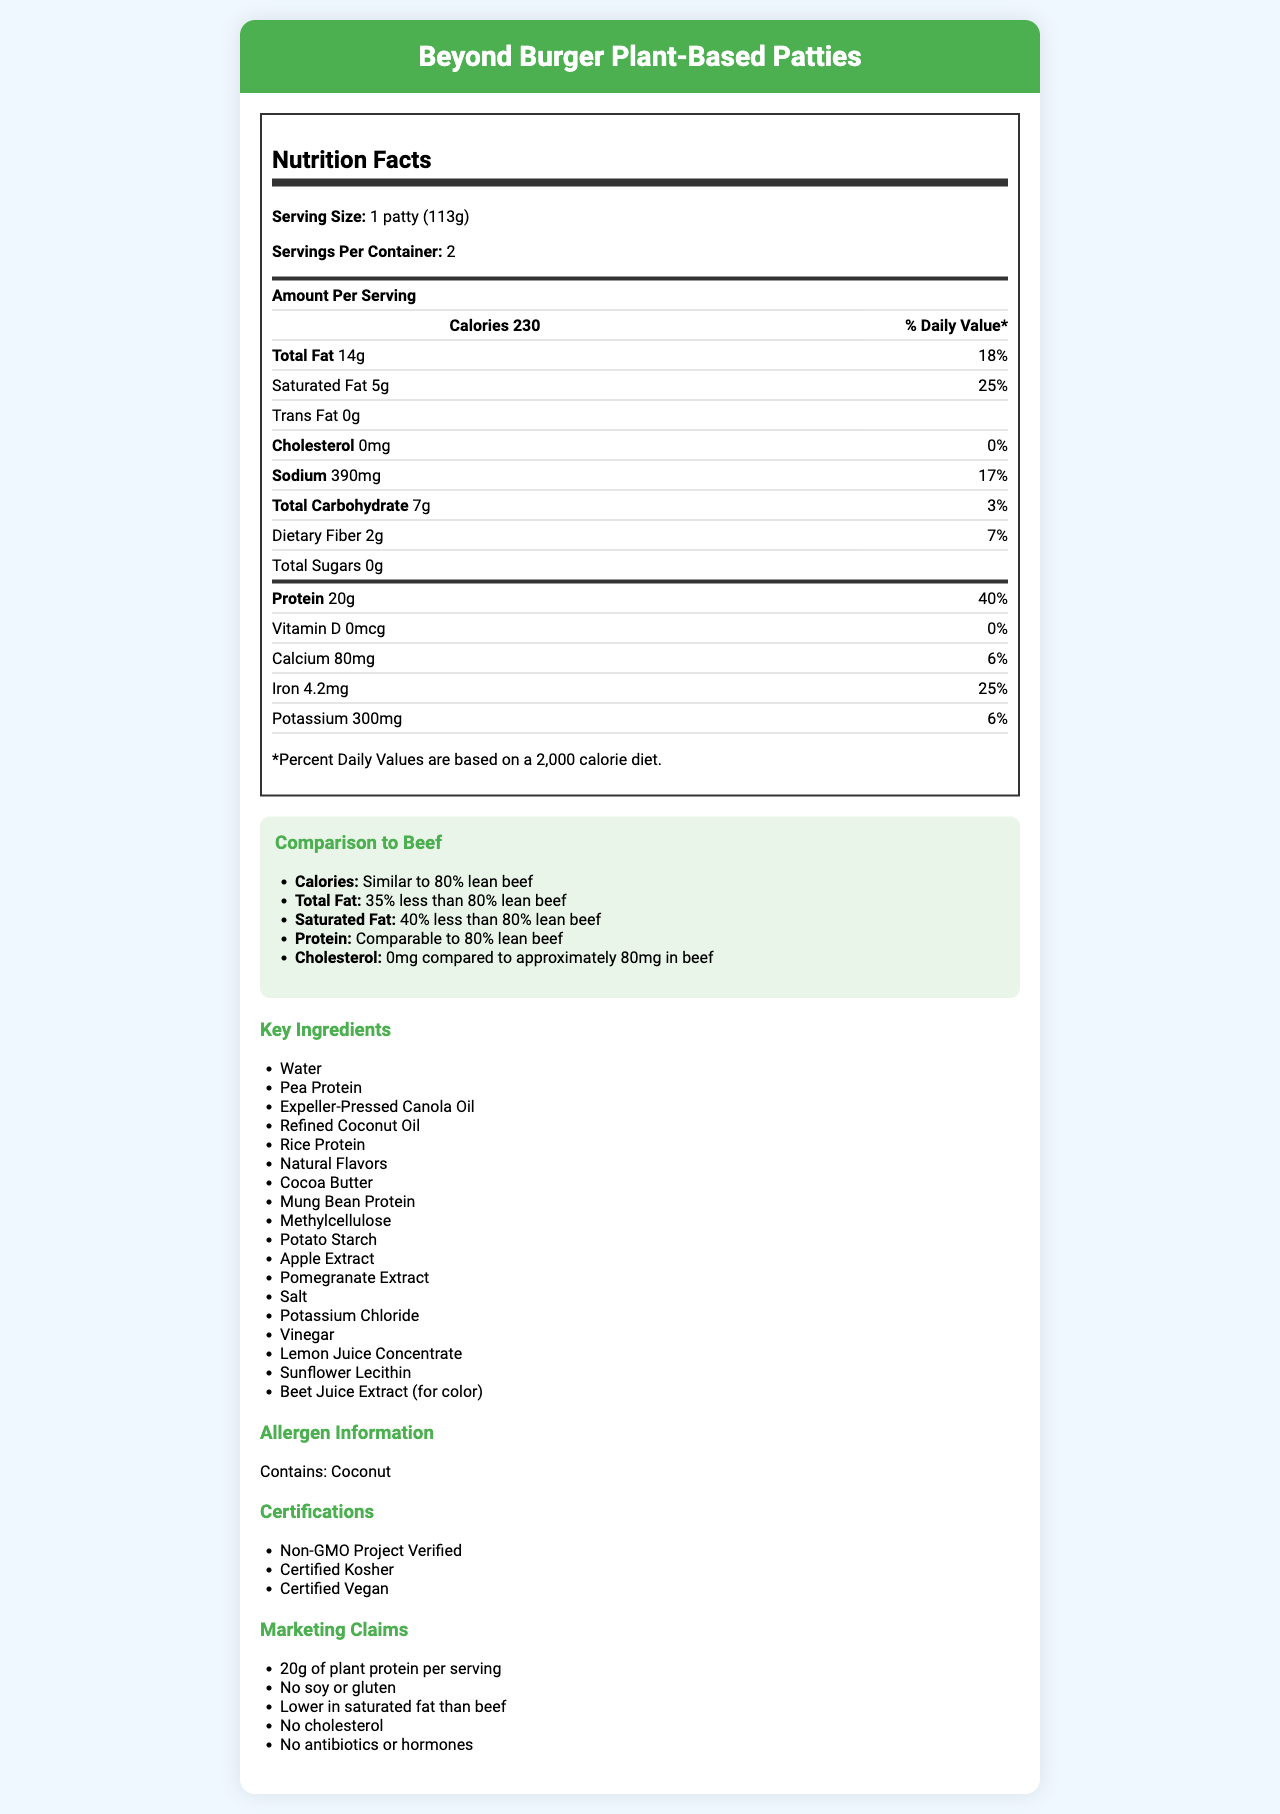What is the serving size of the Beyond Burger Plant-Based Patties? The document states that the serving size is "1 patty (113g)".
Answer: 1 patty (113g) How many calories are there per serving of Beyond Burger Plant-Based Patties? The document lists 230 calories per serving under the "Amount Per Serving" section.
Answer: 230 What percentage of the daily value of protein does one serving of Beyond Burger Plant-Based Patties provide? The nutrition facts list 40% for protein under % Daily Value.
Answer: 40% Are there any allergens mentioned for the Beyond Burger Plant-Based Patties? If so, what are they? The allergen information section states that it contains coconut.
Answer: Coconut How much sodium is there per serving and what percentage of the daily value does it represent? The nutrition facts show 390mg of sodium, which represents 17% of the daily value.
Answer: 390mg, 17% Compared to 80% lean beef, how much less total fat does Beyond Burger have? The comparison section states that the Beyond Burger has 35% less total fat than 80% lean beef.
Answer: 35% less Which of the following certifications does Beyond Burger NOT have? A. Non-GMO Project Verified B. Certified Kosher C. Certified Gluten-Free D. Certified Vegan The document lists "Non-GMO Project Verified", "Certified Kosher", and "Certified Vegan", but not "Certified Gluten-Free".
Answer: C. Certified Gluten-Free What marketing claim about antibiotics is made for Beyond Burger Plant-Based Patties? A. Contains Antibiotics B. No Antibiotics or Hormones C. Antibiotic-Free Beef Alternative D. Antibiotic-Free but Not Hormone-Free The marketing claims section states "No antibiotics or hormones".
Answer: B. No Antibiotics or Hormones Does the Beyond Burger contain trans fats? The document shows "Trans Fat 0g" indicating there are no trans fats.
Answer: No Summarize the main nutritional benefits of Beyond Burger Plant-Based Patties compared to traditional beef products. The document highlights similarities in calories and protein content, with notable reductions in total fat, saturated fat, and cholesterol, along with some added nutritional benefits and certifications.
Answer: The Beyond Burger Plant-Based Patties offer similar calories and protein to 80% lean beef, but with 35% less total fat, 40% less saturated fat, and no cholesterol. Additionally, it provides significant iron and is free of antibiotics and hormones. How many certifications does the Beyond Burger Plant-Based Patties have? The document lists three certifications, but without the document image, it's unclear if there might be additional unlisted certifications.
Answer: Cannot be determined 